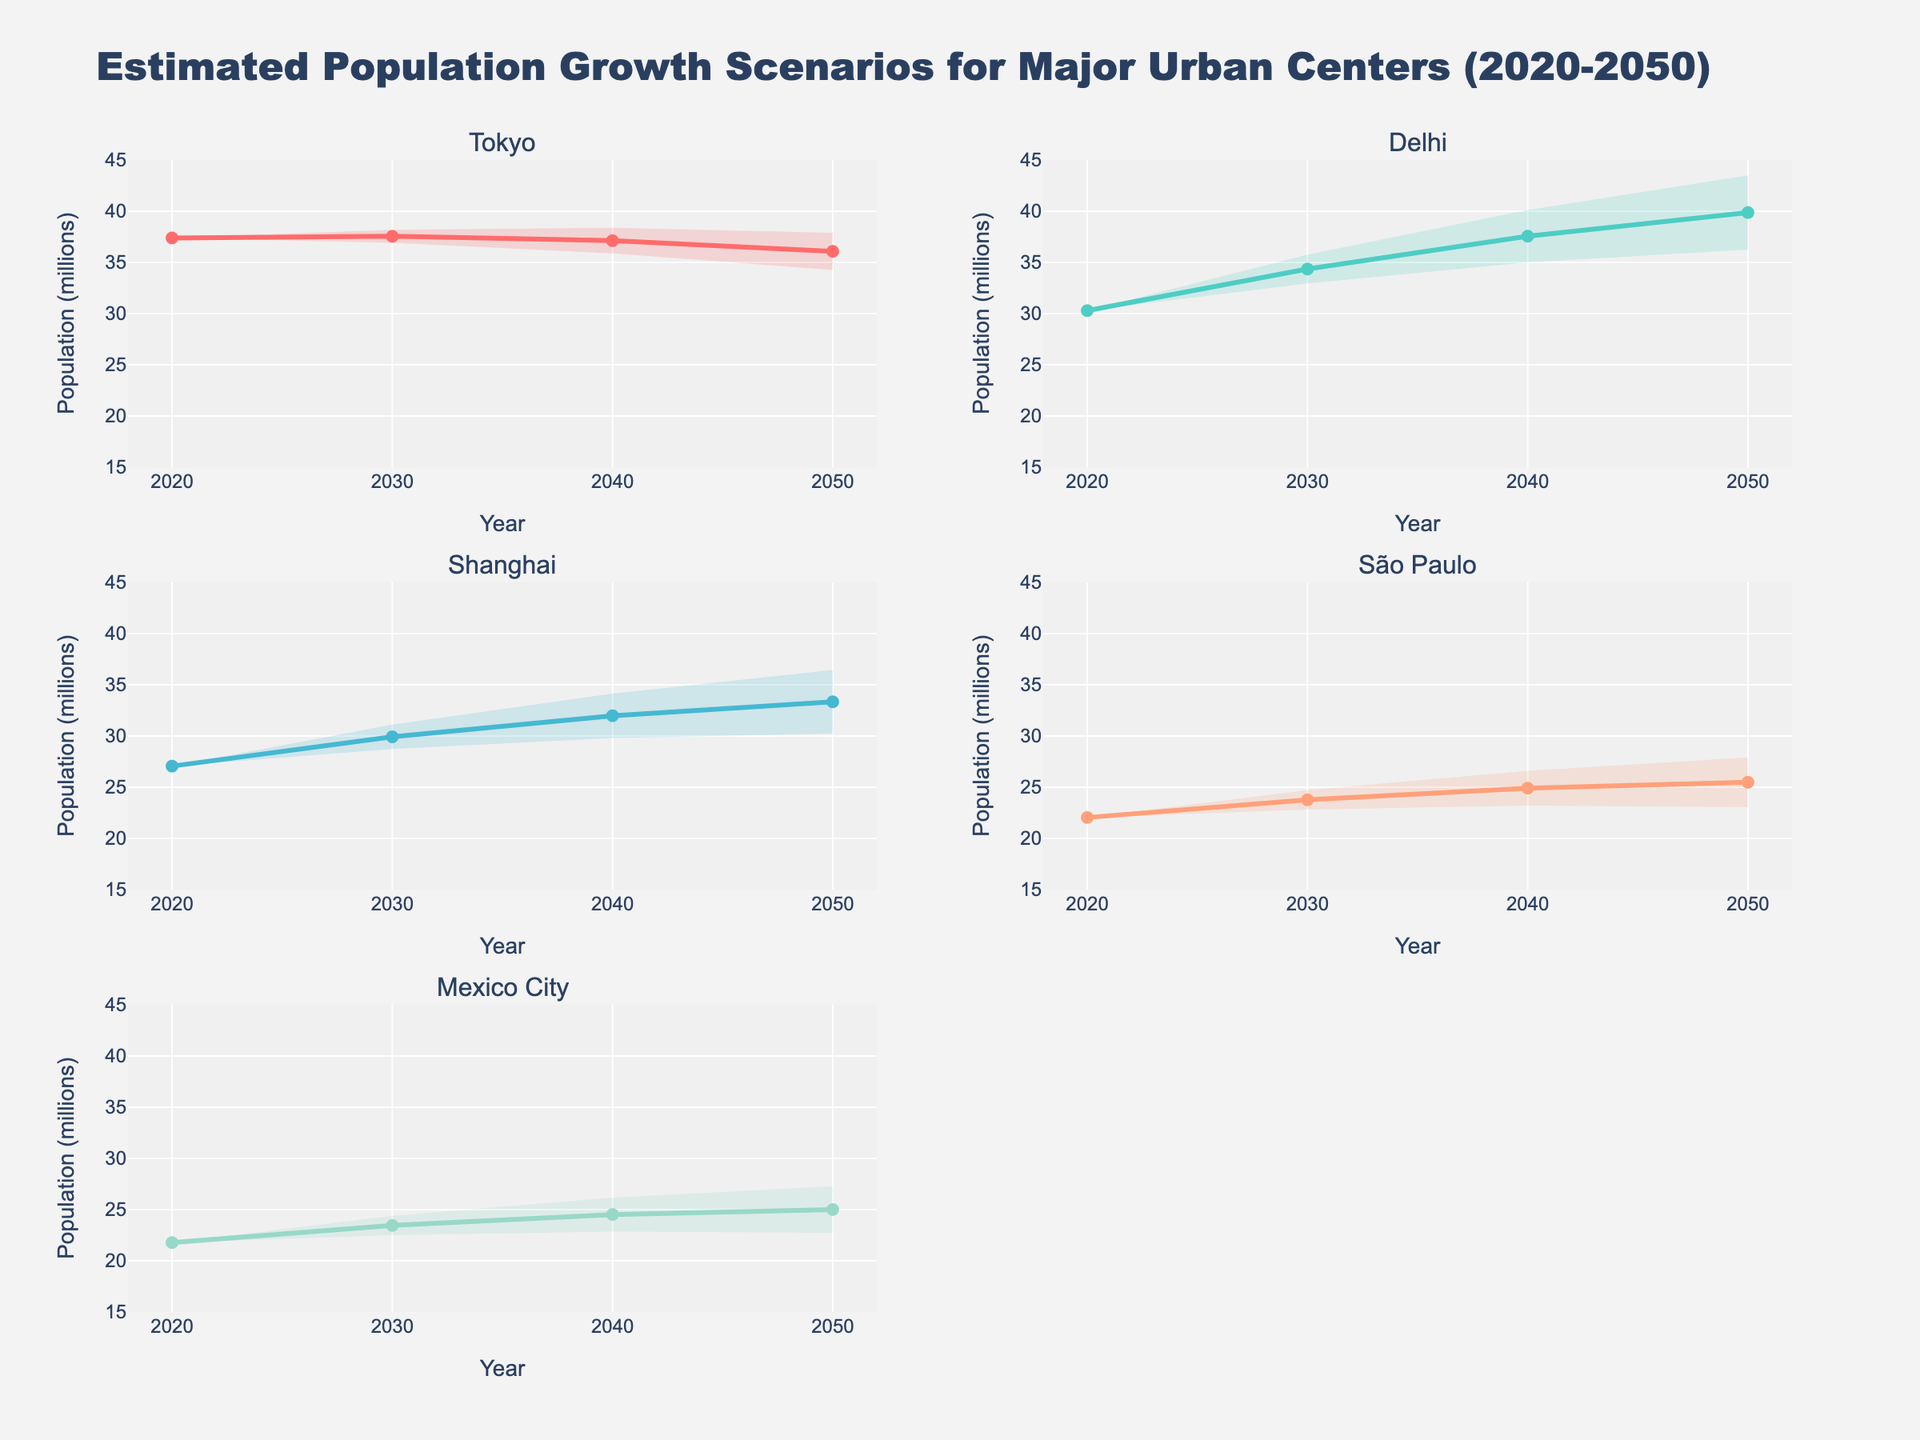What is the title of the figure? The title is found at the top of the figure and provides an overview of what the chart represents. In this case, it is about estimated population growth scenarios for major urban centers through 2050.
Answer: Estimated Population Growth Scenarios for Major Urban Centers (2020-2050) In which year does Delhi have the highest medium estimate population? Look at the medium estimate lines for Delhi and identify the highest y-value along the timeline from 2020 to 2050.
Answer: 2050 What is the population range (low to high estimates) for Tokyo in 2040? To find the population range, check the low and high estimate values for Tokyo in 2040 from the data used for plotting.
Answer: 35.87 to 38.37 million Which city has the smallest projected high estimate population in 2050? Compare the high estimate values for all cities in 2050 and identify the smallest one.
Answer: São Paulo By how much does the medium estimate population of Shanghai increase from 2030 to 2050? Find the medium estimate values for Shanghai in both 2030 and 2050. Subtract the 2030 value from the 2050 value to calculate the increase.
Answer: 3.42 million Which urban center shows the largest increase in the high estimate population from 2020 to 2050? Compare the difference in high estimate population values for all urban centers between 2020 and 2050.
Answer: Delhi What is the average medium estimate population for Mexico City over all the years displayed? Add all the medium estimate population numbers for Mexico City from 2020, 2030, 2040, and 2050, then divide by the number of years (4).
Answer: 23.69 million In which year does São Paulo have the smallest projected low estimate population? Compare the low estimate populations for São Paulo in different years and identify the smallest value.
Answer: 2020 How does the uncertainty (range between low and high estimates) for Delhi change from 2020 to 2050? Calculate the range between low and high estimates for Delhi in both years and see if the difference increases or decreases.
Answer: Increases (from 0 in 2020 to 7.26 million in 2050) Which city has the most stable population estimates, considering the width of the fan over the years? Assess the widths of the fan areas (the distance between low and high estimates) for every city over the years. The smallest width indicates the most stability.
Answer: Tokyo 